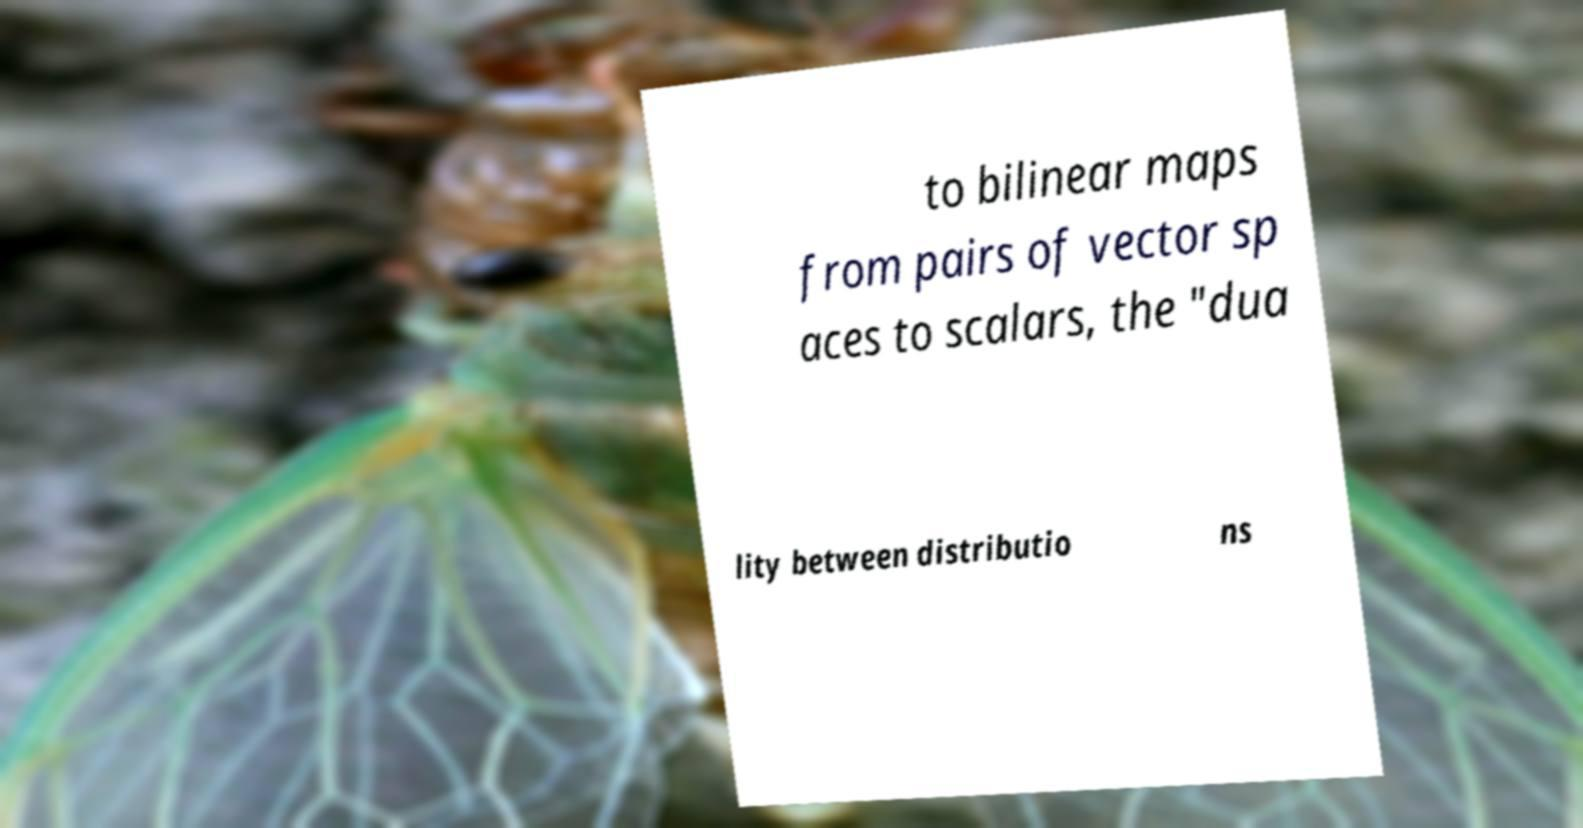What messages or text are displayed in this image? I need them in a readable, typed format. to bilinear maps from pairs of vector sp aces to scalars, the "dua lity between distributio ns 